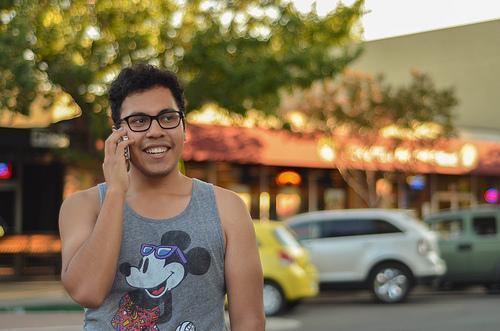How many vehicles are in the background?
Give a very brief answer. 3. How many vehicle can be seen?
Give a very brief answer. 3. 